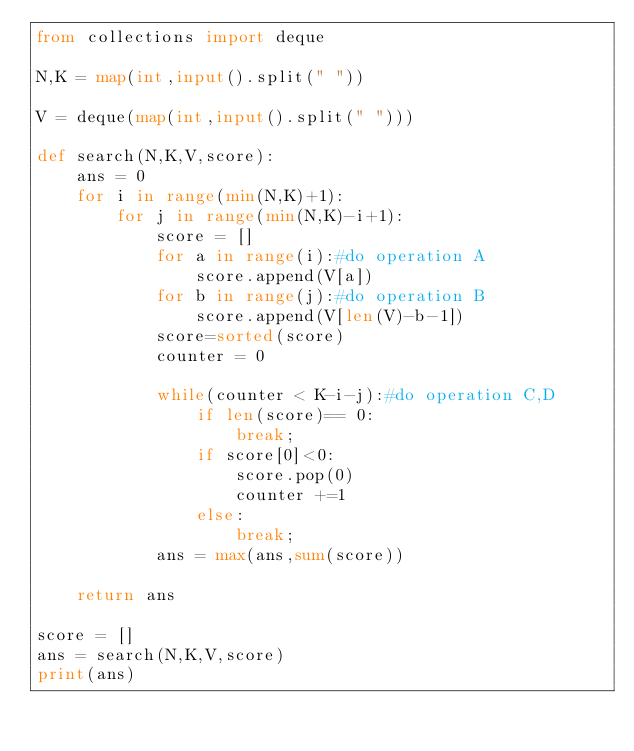<code> <loc_0><loc_0><loc_500><loc_500><_Python_>from collections import deque

N,K = map(int,input().split(" "))

V = deque(map(int,input().split(" ")))

def search(N,K,V,score):
    ans = 0
    for i in range(min(N,K)+1):
        for j in range(min(N,K)-i+1):
            score = []
            for a in range(i):#do operation A
                score.append(V[a])
            for b in range(j):#do operation B
                score.append(V[len(V)-b-1])
            score=sorted(score)
            counter = 0

            while(counter < K-i-j):#do operation C,D
                if len(score)== 0:
                    break;
                if score[0]<0:
                    score.pop(0)
                    counter +=1
                else:
                    break;   
            ans = max(ans,sum(score))

    return ans

score = []
ans = search(N,K,V,score)
print(ans)</code> 